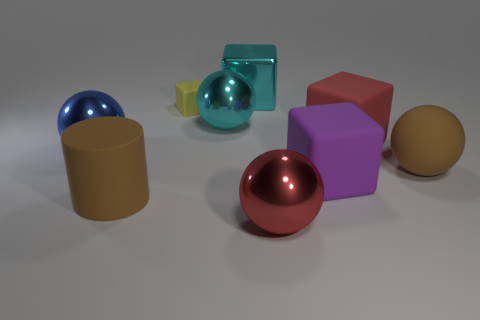There is a cyan object right of the big shiny sphere behind the blue metallic thing; how big is it?
Your response must be concise. Large. Is the size of the blue shiny thing the same as the red matte cube?
Make the answer very short. Yes. There is a brown thing in front of the large brown thing right of the large red shiny sphere; is there a yellow object that is right of it?
Provide a succinct answer. Yes. The yellow matte cube is what size?
Your answer should be very brief. Small. How many blue things have the same size as the red rubber cube?
Your response must be concise. 1. What is the material of the cyan thing that is the same shape as the red rubber object?
Your answer should be compact. Metal. What shape is the large object that is both in front of the purple rubber cube and behind the large red shiny ball?
Offer a terse response. Cylinder. The brown thing that is to the right of the big purple rubber cube has what shape?
Offer a very short reply. Sphere. What number of objects are left of the tiny thing and to the right of the blue ball?
Provide a short and direct response. 1. Do the red matte object and the cube that is on the left side of the cyan metal cube have the same size?
Provide a succinct answer. No. 